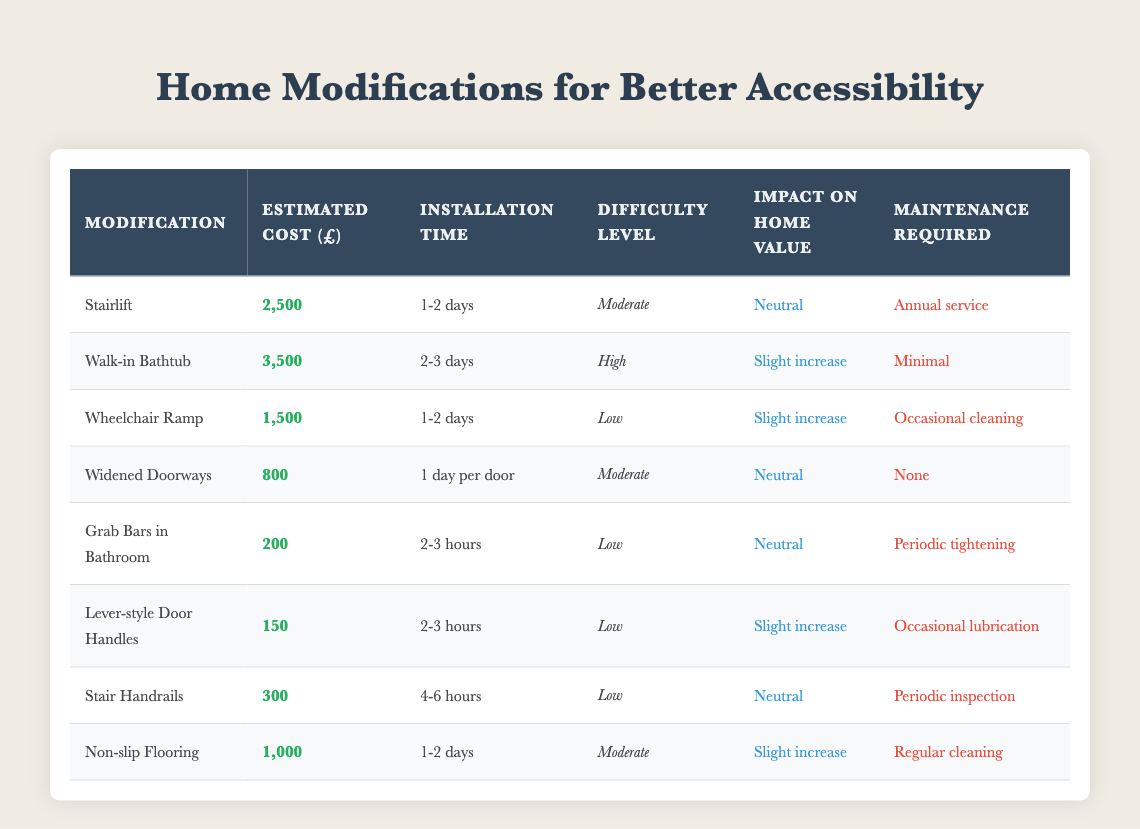What is the estimated cost of installing a Wheelchair Ramp? The table lists the estimated cost for a Wheelchair Ramp as £1,500.
Answer: £1,500 How long does it take to install a Walk-in Bathtub? According to the table, the installation time for a Walk-in Bathtub is 2-3 days.
Answer: 2-3 days Which modifications have a slight increase in impact on home value? By examining the table, both the Walk-in Bathtub, Wheelchair Ramp, Lever-style Door Handles, and Non-slip Flooring show a "Slight increase" in home value impact.
Answer: Walk-in Bathtub, Wheelchair Ramp, Lever-style Door Handles, Non-slip Flooring What is the total estimated cost of all modifications listed? The total estimated cost is the sum of all modifications: 2500 + 3500 + 1500 + 800 + 200 + 150 + 300 + 1000 = 10000.
Answer: £10,000 Is it true that all low difficulty modifications require maintenance? The table indicates that while the Grab Bars in Bathroom, Lever-style Door Handles, and Stair Handrails all fall under a low difficulty level, only Grab Bars and Lever-style Door Handles specify maintenance requirements, thus making the statement false.
Answer: False How much more does a Walk-in Bathtub cost compared to a Grab Bar installation? To find the difference, subtract the cost of Grab Bars (£200) from Walk-in Bathtub (£3500): 3500 - 200 = 3300.
Answer: £3,300 Which modification has the highest estimated cost and what is it? The table shows that the Walk-in Bathtub has the highest estimated cost at £3,500, making it the most expensive modification option.
Answer: Walk-in Bathtub, £3,500 How many modifications require annual service or periodic maintenance? From the table, the Stairlift requires annual service and Grab Bars, Stair Handrails, and Lever-style Door Handles require periodic maintenance, resulting in a total of four modifications needing regular attention.
Answer: 4 